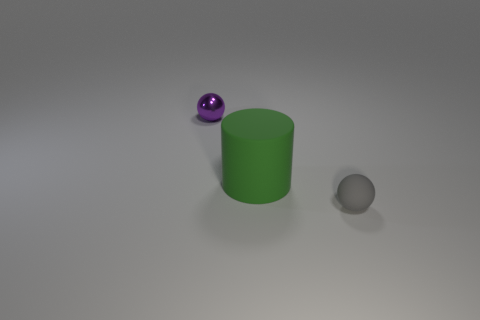There is a sphere left of the small thing in front of the big green matte cylinder; what color is it?
Offer a terse response. Purple. There is a small sphere that is behind the gray thing; does it have the same color as the small rubber thing?
Provide a short and direct response. No. The matte object that is to the left of the small thing that is in front of the metallic thing behind the gray rubber object is what shape?
Make the answer very short. Cylinder. How many small objects are to the right of the purple sphere that is on the left side of the large green matte object?
Keep it short and to the point. 1. Is the green thing made of the same material as the tiny gray object?
Provide a short and direct response. Yes. There is a rubber thing that is on the left side of the tiny thing in front of the purple object; what number of small gray spheres are left of it?
Give a very brief answer. 0. There is a sphere that is behind the small gray matte object; what color is it?
Give a very brief answer. Purple. What is the shape of the rubber thing to the left of the object in front of the large rubber object?
Your answer should be compact. Cylinder. Is the tiny shiny thing the same color as the big object?
Offer a terse response. No. What number of cubes are either gray things or green things?
Provide a short and direct response. 0. 